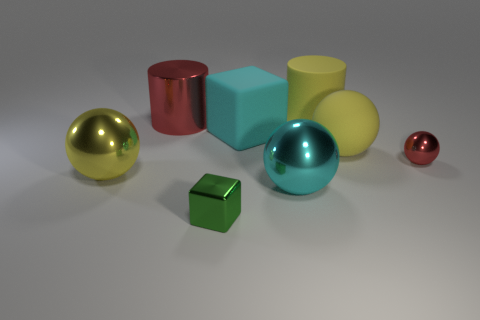Add 2 large yellow balls. How many objects exist? 10 Subtract all gray cubes. How many yellow balls are left? 2 Subtract all small red metal spheres. How many spheres are left? 3 Subtract all red balls. How many balls are left? 3 Subtract 2 balls. How many balls are left? 2 Subtract all purple spheres. Subtract all yellow cubes. How many spheres are left? 4 Subtract all cubes. How many objects are left? 6 Add 8 green objects. How many green objects exist? 9 Subtract 0 green cylinders. How many objects are left? 8 Subtract all metallic objects. Subtract all red objects. How many objects are left? 1 